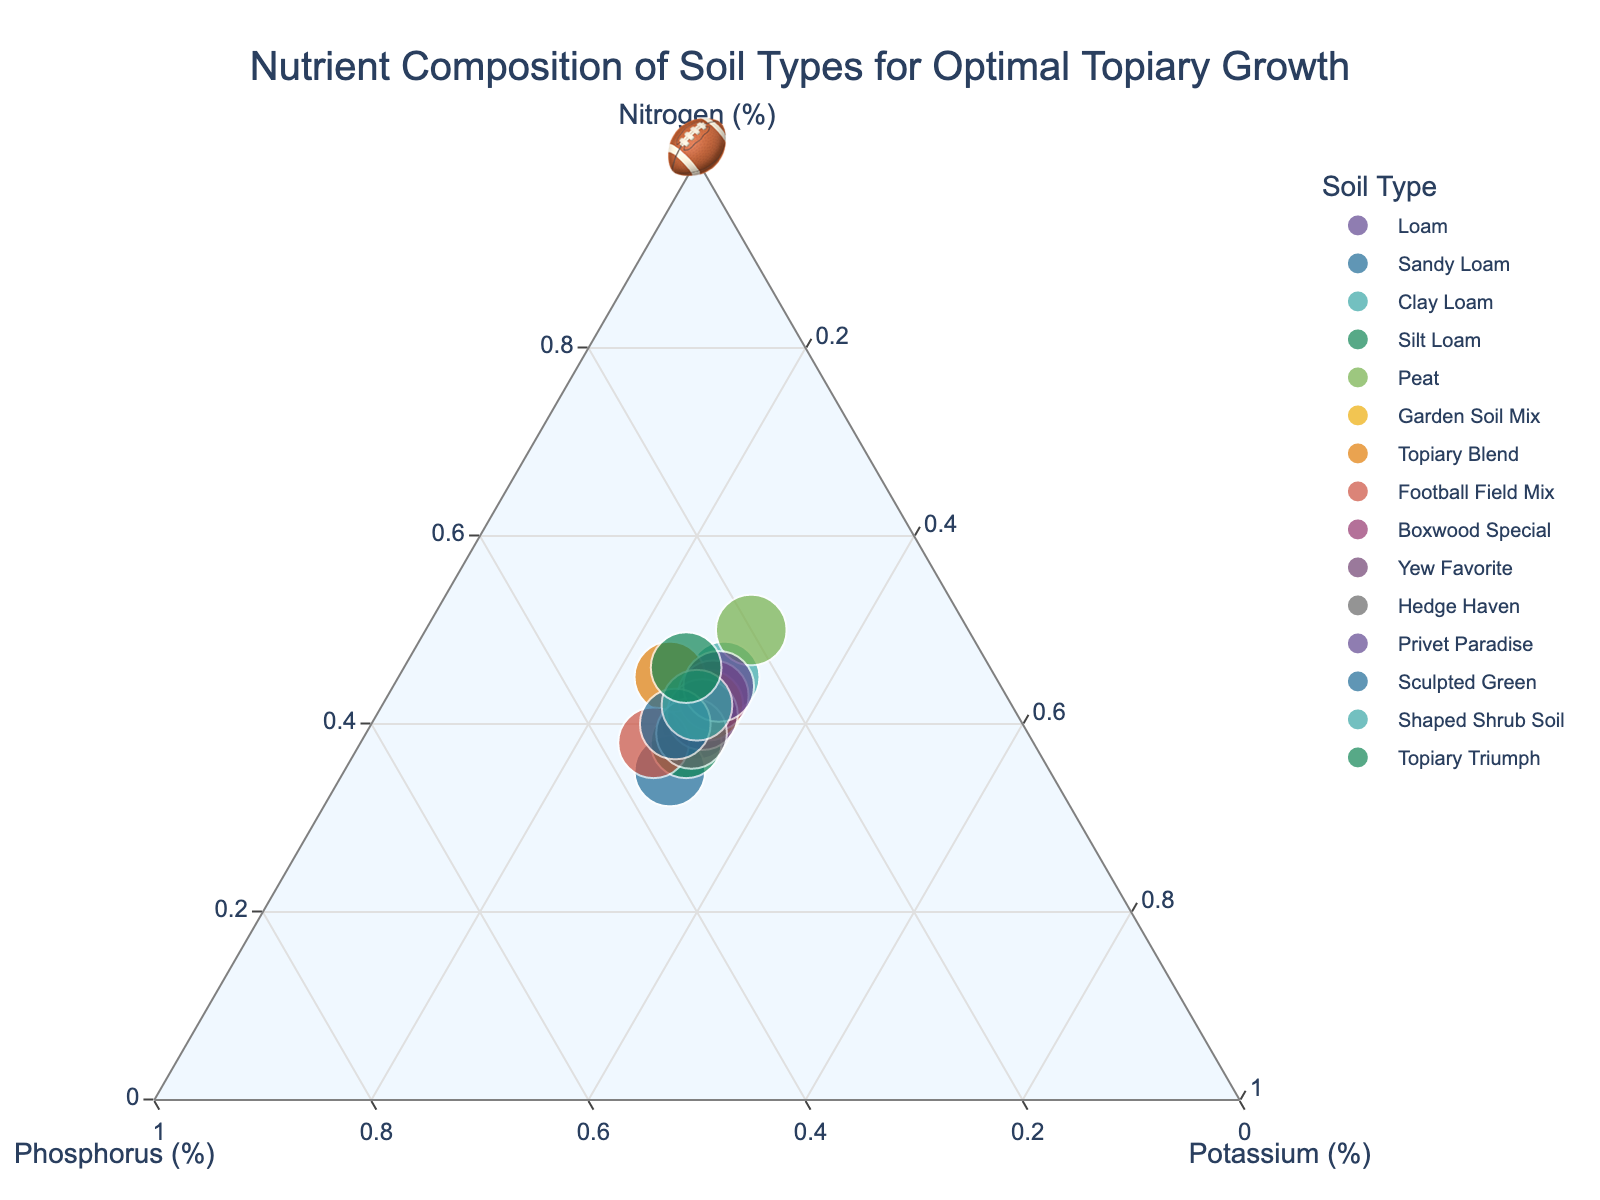How many soil types are represented in the plot? Count the number of distinct colors or data points in the plot. Each color or data point represents a different soil type.
Answer: 15 What is the title of the plot? Look at the top of the plot where the title is written.
Answer: Nutrient Composition of Soil Types for Optimal Topiary Growth Which soil type has the highest nitrogen percentage? Identify the data point closest to the Nitrogen axis (top corner of the ternary plot).
Answer: Topiary Triumph Which soil types have equal percentages of potassium? Look for data points aligned on the same horizontal level referring to the Potassium percentage.
Answer: Loam, Sandy Loam, Clay Loam, Silt Loam, Peat, Garden Soil Mix, Boxwood Special, Yew Favorite, Hedge Haven, Privet Paradise How do the nutrient compositions of 'Football Field Mix' and 'Topiary Blend' compare? Locate the points for both soil types on the plot and compare their coordinates (Nitrogen, Phosphorus, Potassium percentages).
Answer: Football Field Mix: N 38%, P 35%, K 27%; Topiary Blend: N 45%, P 30%, K 25% Which soil type has the most balanced nutrient composition? Find the data point closest to the center of the ternary plot, where percentages of nitrogen, phosphorus, and potassium would be the most balanced (approximately 33% each).
Answer: Sandy Loam What is the total nutrient percentage sum for 'Peat'? Sum the nutrient percentages (N + P + K) from the plot's data points for 'Peat'.
Answer: 100% Which soil type differs the most in nitrogen content from 'Loam'? Compare the nitrogen percentages and find the soil type with the highest difference from 'Loam's nitrogen percentage.
Answer: Peat (difference of 10%) Are there any soil types with more than 50% phosphorus? Check the phosphorus axis to see if any data points are above the 50% line.
Answer: No What can you infer about the potassium percentage across all soil types? Observe the vertical spread of data points along the potassium axis to detect any patterns.
Answer: Almost all soil types have around 30% potassium 